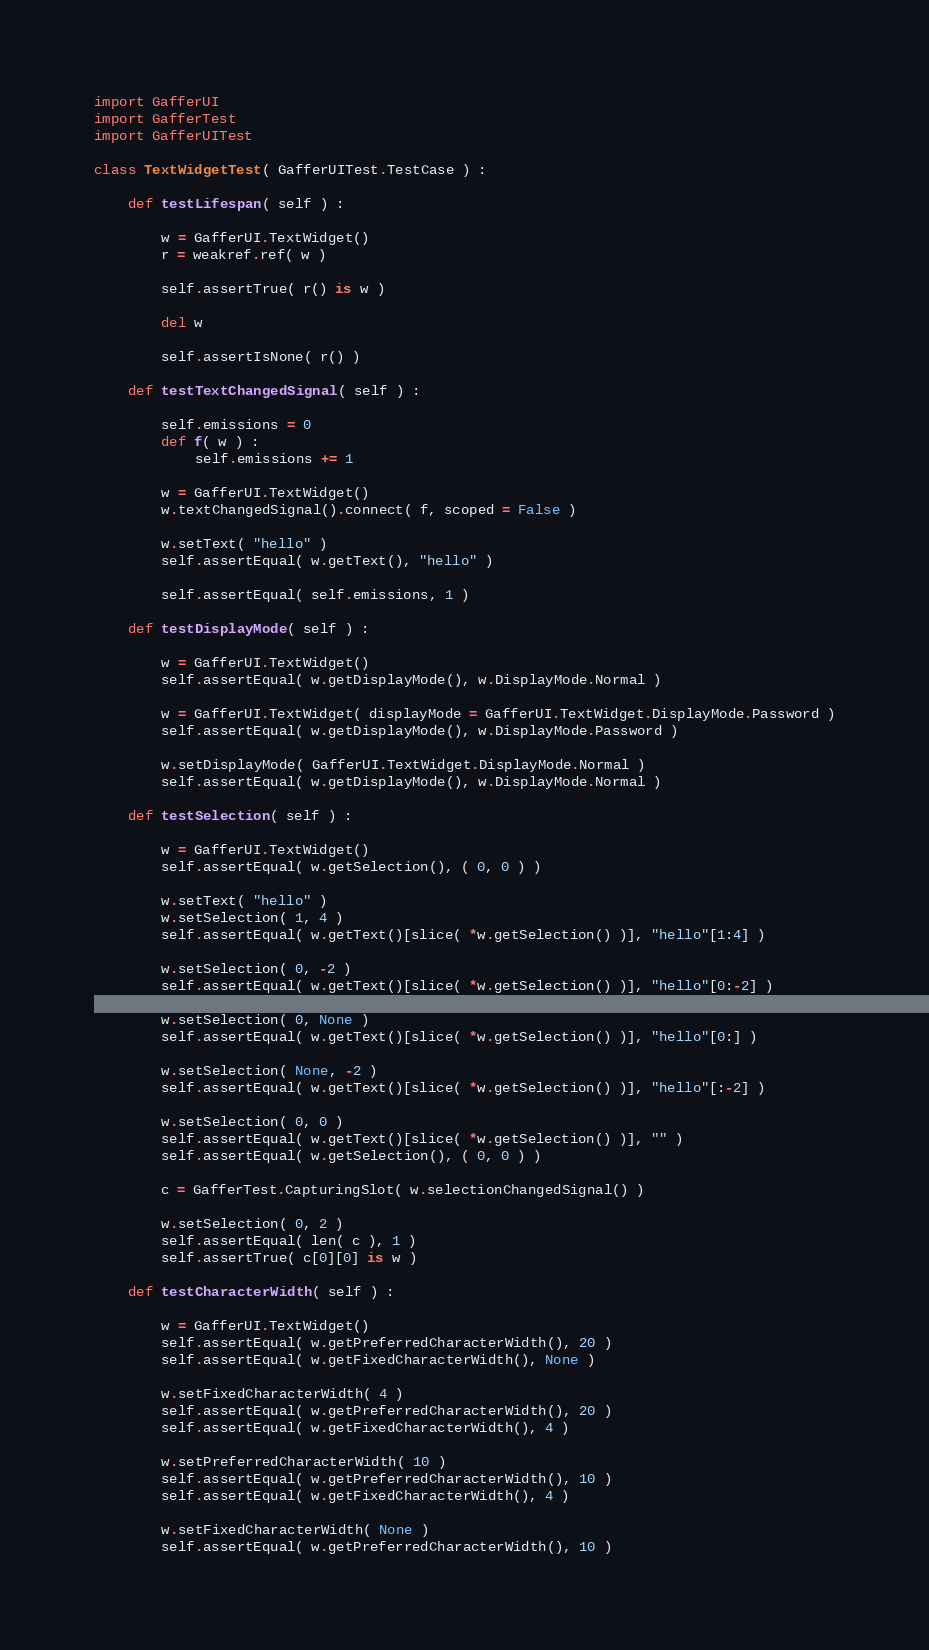Convert code to text. <code><loc_0><loc_0><loc_500><loc_500><_Python_>
import GafferUI
import GafferTest
import GafferUITest

class TextWidgetTest( GafferUITest.TestCase ) :

	def testLifespan( self ) :

		w = GafferUI.TextWidget()
		r = weakref.ref( w )

		self.assertTrue( r() is w )

		del w

		self.assertIsNone( r() )

	def testTextChangedSignal( self ) :

		self.emissions = 0
		def f( w ) :
			self.emissions += 1

		w = GafferUI.TextWidget()
		w.textChangedSignal().connect( f, scoped = False )

		w.setText( "hello" )
		self.assertEqual( w.getText(), "hello" )

		self.assertEqual( self.emissions, 1 )

	def testDisplayMode( self ) :

		w = GafferUI.TextWidget()
		self.assertEqual( w.getDisplayMode(), w.DisplayMode.Normal )

		w = GafferUI.TextWidget( displayMode = GafferUI.TextWidget.DisplayMode.Password )
		self.assertEqual( w.getDisplayMode(), w.DisplayMode.Password )

		w.setDisplayMode( GafferUI.TextWidget.DisplayMode.Normal )
		self.assertEqual( w.getDisplayMode(), w.DisplayMode.Normal )

	def testSelection( self ) :

		w = GafferUI.TextWidget()
		self.assertEqual( w.getSelection(), ( 0, 0 ) )

		w.setText( "hello" )
		w.setSelection( 1, 4 )
		self.assertEqual( w.getText()[slice( *w.getSelection() )], "hello"[1:4] )

		w.setSelection( 0, -2 )
		self.assertEqual( w.getText()[slice( *w.getSelection() )], "hello"[0:-2] )

		w.setSelection( 0, None )
		self.assertEqual( w.getText()[slice( *w.getSelection() )], "hello"[0:] )

		w.setSelection( None, -2 )
		self.assertEqual( w.getText()[slice( *w.getSelection() )], "hello"[:-2] )

		w.setSelection( 0, 0 )
		self.assertEqual( w.getText()[slice( *w.getSelection() )], "" )
		self.assertEqual( w.getSelection(), ( 0, 0 ) )

		c = GafferTest.CapturingSlot( w.selectionChangedSignal() )

		w.setSelection( 0, 2 )
		self.assertEqual( len( c ), 1 )
		self.assertTrue( c[0][0] is w )

	def testCharacterWidth( self ) :

		w = GafferUI.TextWidget()
		self.assertEqual( w.getPreferredCharacterWidth(), 20 )
		self.assertEqual( w.getFixedCharacterWidth(), None )

		w.setFixedCharacterWidth( 4 )
		self.assertEqual( w.getPreferredCharacterWidth(), 20 )
		self.assertEqual( w.getFixedCharacterWidth(), 4 )

		w.setPreferredCharacterWidth( 10 )
		self.assertEqual( w.getPreferredCharacterWidth(), 10 )
		self.assertEqual( w.getFixedCharacterWidth(), 4 )

		w.setFixedCharacterWidth( None )
		self.assertEqual( w.getPreferredCharacterWidth(), 10 )</code> 